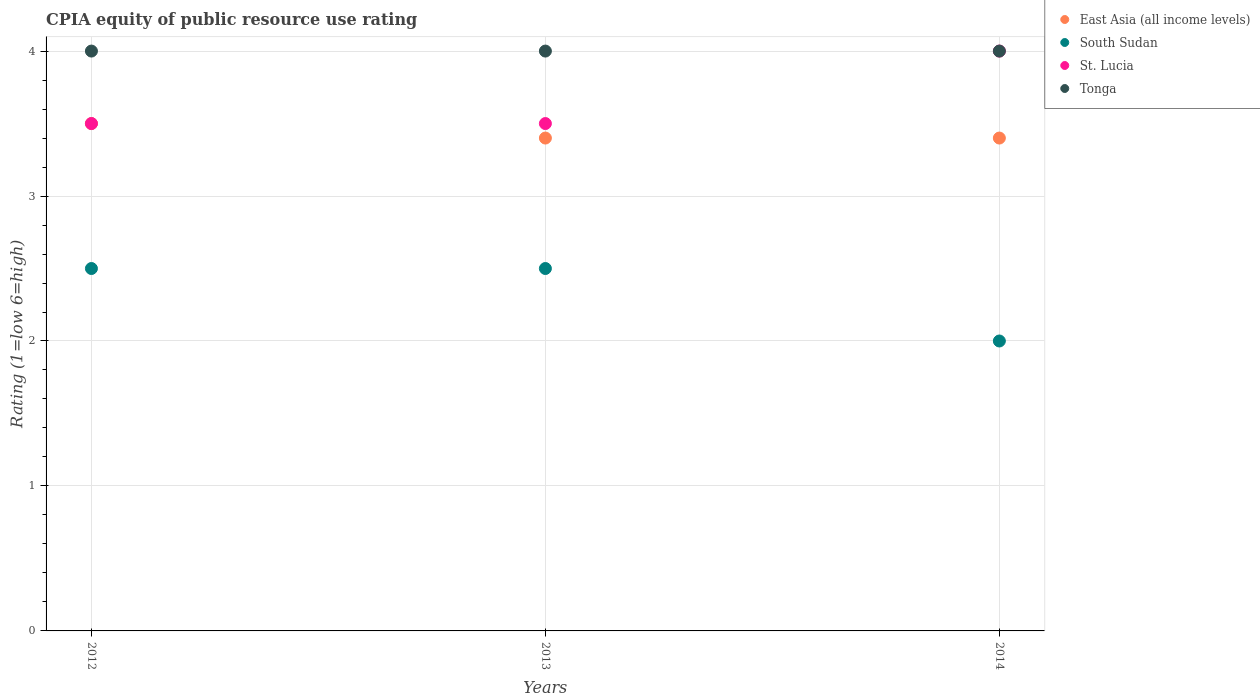How many different coloured dotlines are there?
Your response must be concise. 4. Across all years, what is the maximum CPIA rating in South Sudan?
Ensure brevity in your answer.  2.5. In which year was the CPIA rating in East Asia (all income levels) maximum?
Ensure brevity in your answer.  2012. In which year was the CPIA rating in Tonga minimum?
Your answer should be very brief. 2012. What is the average CPIA rating in South Sudan per year?
Ensure brevity in your answer.  2.33. What is the ratio of the CPIA rating in South Sudan in 2013 to that in 2014?
Make the answer very short. 1.25. What is the difference between the highest and the second highest CPIA rating in South Sudan?
Provide a short and direct response. 0. What is the difference between the highest and the lowest CPIA rating in South Sudan?
Ensure brevity in your answer.  0.5. Is the sum of the CPIA rating in East Asia (all income levels) in 2012 and 2013 greater than the maximum CPIA rating in St. Lucia across all years?
Your answer should be compact. Yes. Is it the case that in every year, the sum of the CPIA rating in St. Lucia and CPIA rating in Tonga  is greater than the sum of CPIA rating in South Sudan and CPIA rating in East Asia (all income levels)?
Offer a very short reply. Yes. Is it the case that in every year, the sum of the CPIA rating in Tonga and CPIA rating in South Sudan  is greater than the CPIA rating in St. Lucia?
Offer a very short reply. Yes. Is the CPIA rating in St. Lucia strictly greater than the CPIA rating in Tonga over the years?
Your answer should be compact. No. Is the CPIA rating in St. Lucia strictly less than the CPIA rating in East Asia (all income levels) over the years?
Your answer should be compact. No. How many years are there in the graph?
Provide a short and direct response. 3. What is the difference between two consecutive major ticks on the Y-axis?
Provide a succinct answer. 1. Where does the legend appear in the graph?
Ensure brevity in your answer.  Top right. What is the title of the graph?
Provide a succinct answer. CPIA equity of public resource use rating. What is the label or title of the Y-axis?
Make the answer very short. Rating (1=low 6=high). What is the Rating (1=low 6=high) in St. Lucia in 2012?
Keep it short and to the point. 3.5. What is the Rating (1=low 6=high) of Tonga in 2012?
Offer a terse response. 4. What is the Rating (1=low 6=high) in East Asia (all income levels) in 2013?
Provide a succinct answer. 3.4. What is the Rating (1=low 6=high) of St. Lucia in 2013?
Your answer should be compact. 3.5. What is the Rating (1=low 6=high) of East Asia (all income levels) in 2014?
Provide a succinct answer. 3.4. What is the Rating (1=low 6=high) of St. Lucia in 2014?
Your answer should be very brief. 4. Across all years, what is the maximum Rating (1=low 6=high) of East Asia (all income levels)?
Provide a succinct answer. 3.5. Across all years, what is the maximum Rating (1=low 6=high) of South Sudan?
Offer a very short reply. 2.5. Across all years, what is the maximum Rating (1=low 6=high) in Tonga?
Your answer should be compact. 4. Across all years, what is the minimum Rating (1=low 6=high) in South Sudan?
Give a very brief answer. 2. What is the total Rating (1=low 6=high) in St. Lucia in the graph?
Give a very brief answer. 11. What is the difference between the Rating (1=low 6=high) in St. Lucia in 2012 and that in 2013?
Your response must be concise. 0. What is the difference between the Rating (1=low 6=high) of Tonga in 2012 and that in 2013?
Offer a very short reply. 0. What is the difference between the Rating (1=low 6=high) in South Sudan in 2012 and that in 2014?
Make the answer very short. 0.5. What is the difference between the Rating (1=low 6=high) of Tonga in 2012 and that in 2014?
Give a very brief answer. 0. What is the difference between the Rating (1=low 6=high) of East Asia (all income levels) in 2013 and that in 2014?
Provide a succinct answer. 0. What is the difference between the Rating (1=low 6=high) of Tonga in 2013 and that in 2014?
Your answer should be compact. 0. What is the difference between the Rating (1=low 6=high) in East Asia (all income levels) in 2012 and the Rating (1=low 6=high) in South Sudan in 2013?
Provide a succinct answer. 1. What is the difference between the Rating (1=low 6=high) in South Sudan in 2012 and the Rating (1=low 6=high) in St. Lucia in 2013?
Offer a very short reply. -1. What is the difference between the Rating (1=low 6=high) in South Sudan in 2012 and the Rating (1=low 6=high) in Tonga in 2013?
Your answer should be very brief. -1.5. What is the difference between the Rating (1=low 6=high) of East Asia (all income levels) in 2012 and the Rating (1=low 6=high) of South Sudan in 2014?
Offer a very short reply. 1.5. What is the difference between the Rating (1=low 6=high) in East Asia (all income levels) in 2012 and the Rating (1=low 6=high) in Tonga in 2014?
Give a very brief answer. -0.5. What is the difference between the Rating (1=low 6=high) in South Sudan in 2012 and the Rating (1=low 6=high) in St. Lucia in 2014?
Your answer should be compact. -1.5. What is the difference between the Rating (1=low 6=high) of South Sudan in 2012 and the Rating (1=low 6=high) of Tonga in 2014?
Provide a succinct answer. -1.5. What is the difference between the Rating (1=low 6=high) of East Asia (all income levels) in 2013 and the Rating (1=low 6=high) of St. Lucia in 2014?
Provide a short and direct response. -0.6. What is the difference between the Rating (1=low 6=high) in South Sudan in 2013 and the Rating (1=low 6=high) in Tonga in 2014?
Offer a very short reply. -1.5. What is the average Rating (1=low 6=high) of East Asia (all income levels) per year?
Your response must be concise. 3.43. What is the average Rating (1=low 6=high) of South Sudan per year?
Your answer should be very brief. 2.33. What is the average Rating (1=low 6=high) of St. Lucia per year?
Offer a very short reply. 3.67. In the year 2013, what is the difference between the Rating (1=low 6=high) of South Sudan and Rating (1=low 6=high) of Tonga?
Keep it short and to the point. -1.5. In the year 2014, what is the difference between the Rating (1=low 6=high) of East Asia (all income levels) and Rating (1=low 6=high) of South Sudan?
Ensure brevity in your answer.  1.4. In the year 2014, what is the difference between the Rating (1=low 6=high) of East Asia (all income levels) and Rating (1=low 6=high) of Tonga?
Provide a succinct answer. -0.6. In the year 2014, what is the difference between the Rating (1=low 6=high) of South Sudan and Rating (1=low 6=high) of St. Lucia?
Provide a succinct answer. -2. In the year 2014, what is the difference between the Rating (1=low 6=high) of St. Lucia and Rating (1=low 6=high) of Tonga?
Provide a succinct answer. 0. What is the ratio of the Rating (1=low 6=high) of East Asia (all income levels) in 2012 to that in 2013?
Give a very brief answer. 1.03. What is the ratio of the Rating (1=low 6=high) of South Sudan in 2012 to that in 2013?
Offer a terse response. 1. What is the ratio of the Rating (1=low 6=high) in St. Lucia in 2012 to that in 2013?
Make the answer very short. 1. What is the ratio of the Rating (1=low 6=high) in Tonga in 2012 to that in 2013?
Provide a succinct answer. 1. What is the ratio of the Rating (1=low 6=high) in East Asia (all income levels) in 2012 to that in 2014?
Keep it short and to the point. 1.03. What is the ratio of the Rating (1=low 6=high) in St. Lucia in 2012 to that in 2014?
Give a very brief answer. 0.88. What is the ratio of the Rating (1=low 6=high) in Tonga in 2012 to that in 2014?
Keep it short and to the point. 1. What is the ratio of the Rating (1=low 6=high) in East Asia (all income levels) in 2013 to that in 2014?
Offer a very short reply. 1. What is the ratio of the Rating (1=low 6=high) in Tonga in 2013 to that in 2014?
Keep it short and to the point. 1. What is the difference between the highest and the second highest Rating (1=low 6=high) in South Sudan?
Your answer should be very brief. 0. What is the difference between the highest and the second highest Rating (1=low 6=high) of St. Lucia?
Give a very brief answer. 0.5. What is the difference between the highest and the second highest Rating (1=low 6=high) of Tonga?
Ensure brevity in your answer.  0. 